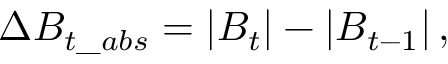<formula> <loc_0><loc_0><loc_500><loc_500>\Delta B _ { t \_ a b s } = \left | B _ { t } \right | - \left | B _ { t - 1 } \right | ,</formula> 